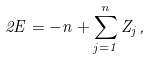<formula> <loc_0><loc_0><loc_500><loc_500>2 E = - n + \sum _ { j = 1 } ^ { n } Z _ { j } \, ,</formula> 